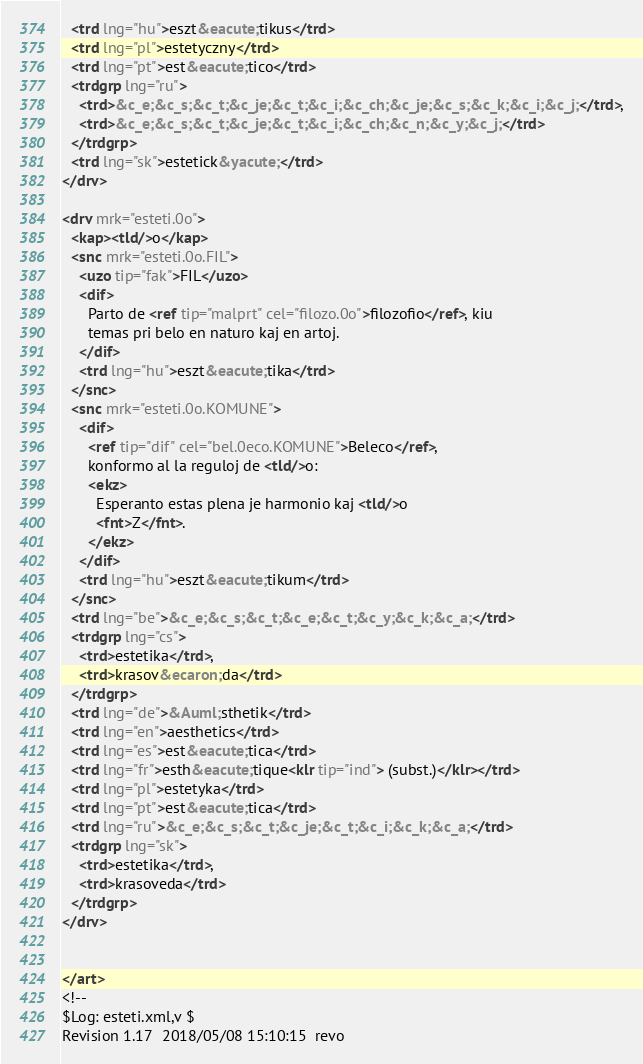<code> <loc_0><loc_0><loc_500><loc_500><_XML_>  <trd lng="hu">eszt&eacute;tikus</trd>
  <trd lng="pl">estetyczny</trd>
  <trd lng="pt">est&eacute;tico</trd>
  <trdgrp lng="ru">
    <trd>&c_e;&c_s;&c_t;&c_je;&c_t;&c_i;&c_ch;&c_je;&c_s;&c_k;&c_i;&c_j;</trd>,
    <trd>&c_e;&c_s;&c_t;&c_je;&c_t;&c_i;&c_ch;&c_n;&c_y;&c_j;</trd>
  </trdgrp>
  <trd lng="sk">estetick&yacute;</trd>
</drv>

<drv mrk="esteti.0o">
  <kap><tld/>o</kap>
  <snc mrk="esteti.0o.FIL">
    <uzo tip="fak">FIL</uzo>
    <dif>
      Parto de <ref tip="malprt" cel="filozo.0o">filozofio</ref>, kiu
      temas pri belo en naturo kaj en artoj. 
    </dif>
    <trd lng="hu">eszt&eacute;tika</trd>
  </snc>
  <snc mrk="esteti.0o.KOMUNE">
    <dif>
      <ref tip="dif" cel="bel.0eco.KOMUNE">Beleco</ref>,
      konformo al la reguloj de <tld/>o:
      <ekz>
        Esperanto estas plena je harmonio kaj <tld/>o
        <fnt>Z</fnt>.
      </ekz> 
    </dif>
    <trd lng="hu">eszt&eacute;tikum</trd>
  </snc>
  <trd lng="be">&c_e;&c_s;&c_t;&c_e;&c_t;&c_y;&c_k;&c_a;</trd>
  <trdgrp lng="cs">
    <trd>estetika</trd>,
    <trd>krasov&ecaron;da</trd>
  </trdgrp>
  <trd lng="de">&Auml;sthetik</trd>
  <trd lng="en">aesthetics</trd>
  <trd lng="es">est&eacute;tica</trd>
  <trd lng="fr">esth&eacute;tique<klr tip="ind"> (subst.)</klr></trd>
  <trd lng="pl">estetyka</trd>
  <trd lng="pt">est&eacute;tica</trd>
  <trd lng="ru">&c_e;&c_s;&c_t;&c_je;&c_t;&c_i;&c_k;&c_a;</trd>
  <trdgrp lng="sk">
    <trd>estetika</trd>,
    <trd>krasoveda</trd>
  </trdgrp>
</drv>


</art>
<!--
$Log: esteti.xml,v $
Revision 1.17  2018/05/08 15:10:15  revo</code> 